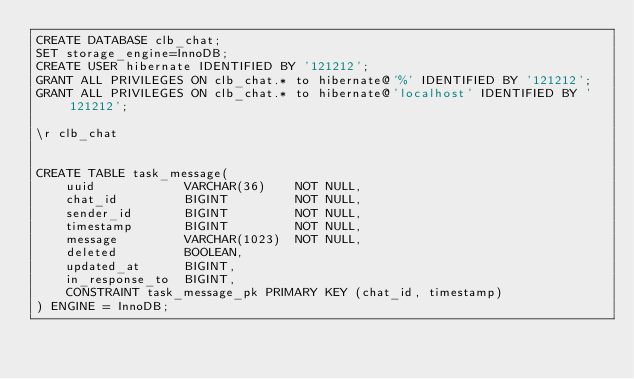<code> <loc_0><loc_0><loc_500><loc_500><_SQL_>CREATE DATABASE clb_chat;
SET storage_engine=InnoDB;
CREATE USER hibernate IDENTIFIED BY '121212';
GRANT ALL PRIVILEGES ON clb_chat.* to hibernate@'%' IDENTIFIED BY '121212';
GRANT ALL PRIVILEGES ON clb_chat.* to hibernate@'localhost' IDENTIFIED BY '121212';

\r clb_chat


CREATE TABLE task_message(
	uuid            VARCHAR(36)    NOT NULL,
	chat_id         BIGINT         NOT NULL,
	sender_id       BIGINT         NOT NULL,
	timestamp       BIGINT         NOT NULL,
	message         VARCHAR(1023)  NOT NULL,
	deleted         BOOLEAN,
	updated_at      BIGINT,
	in_response_to  BIGINT,
	CONSTRAINT task_message_pk PRIMARY KEY (chat_id, timestamp)
) ENGINE = InnoDB;
</code> 